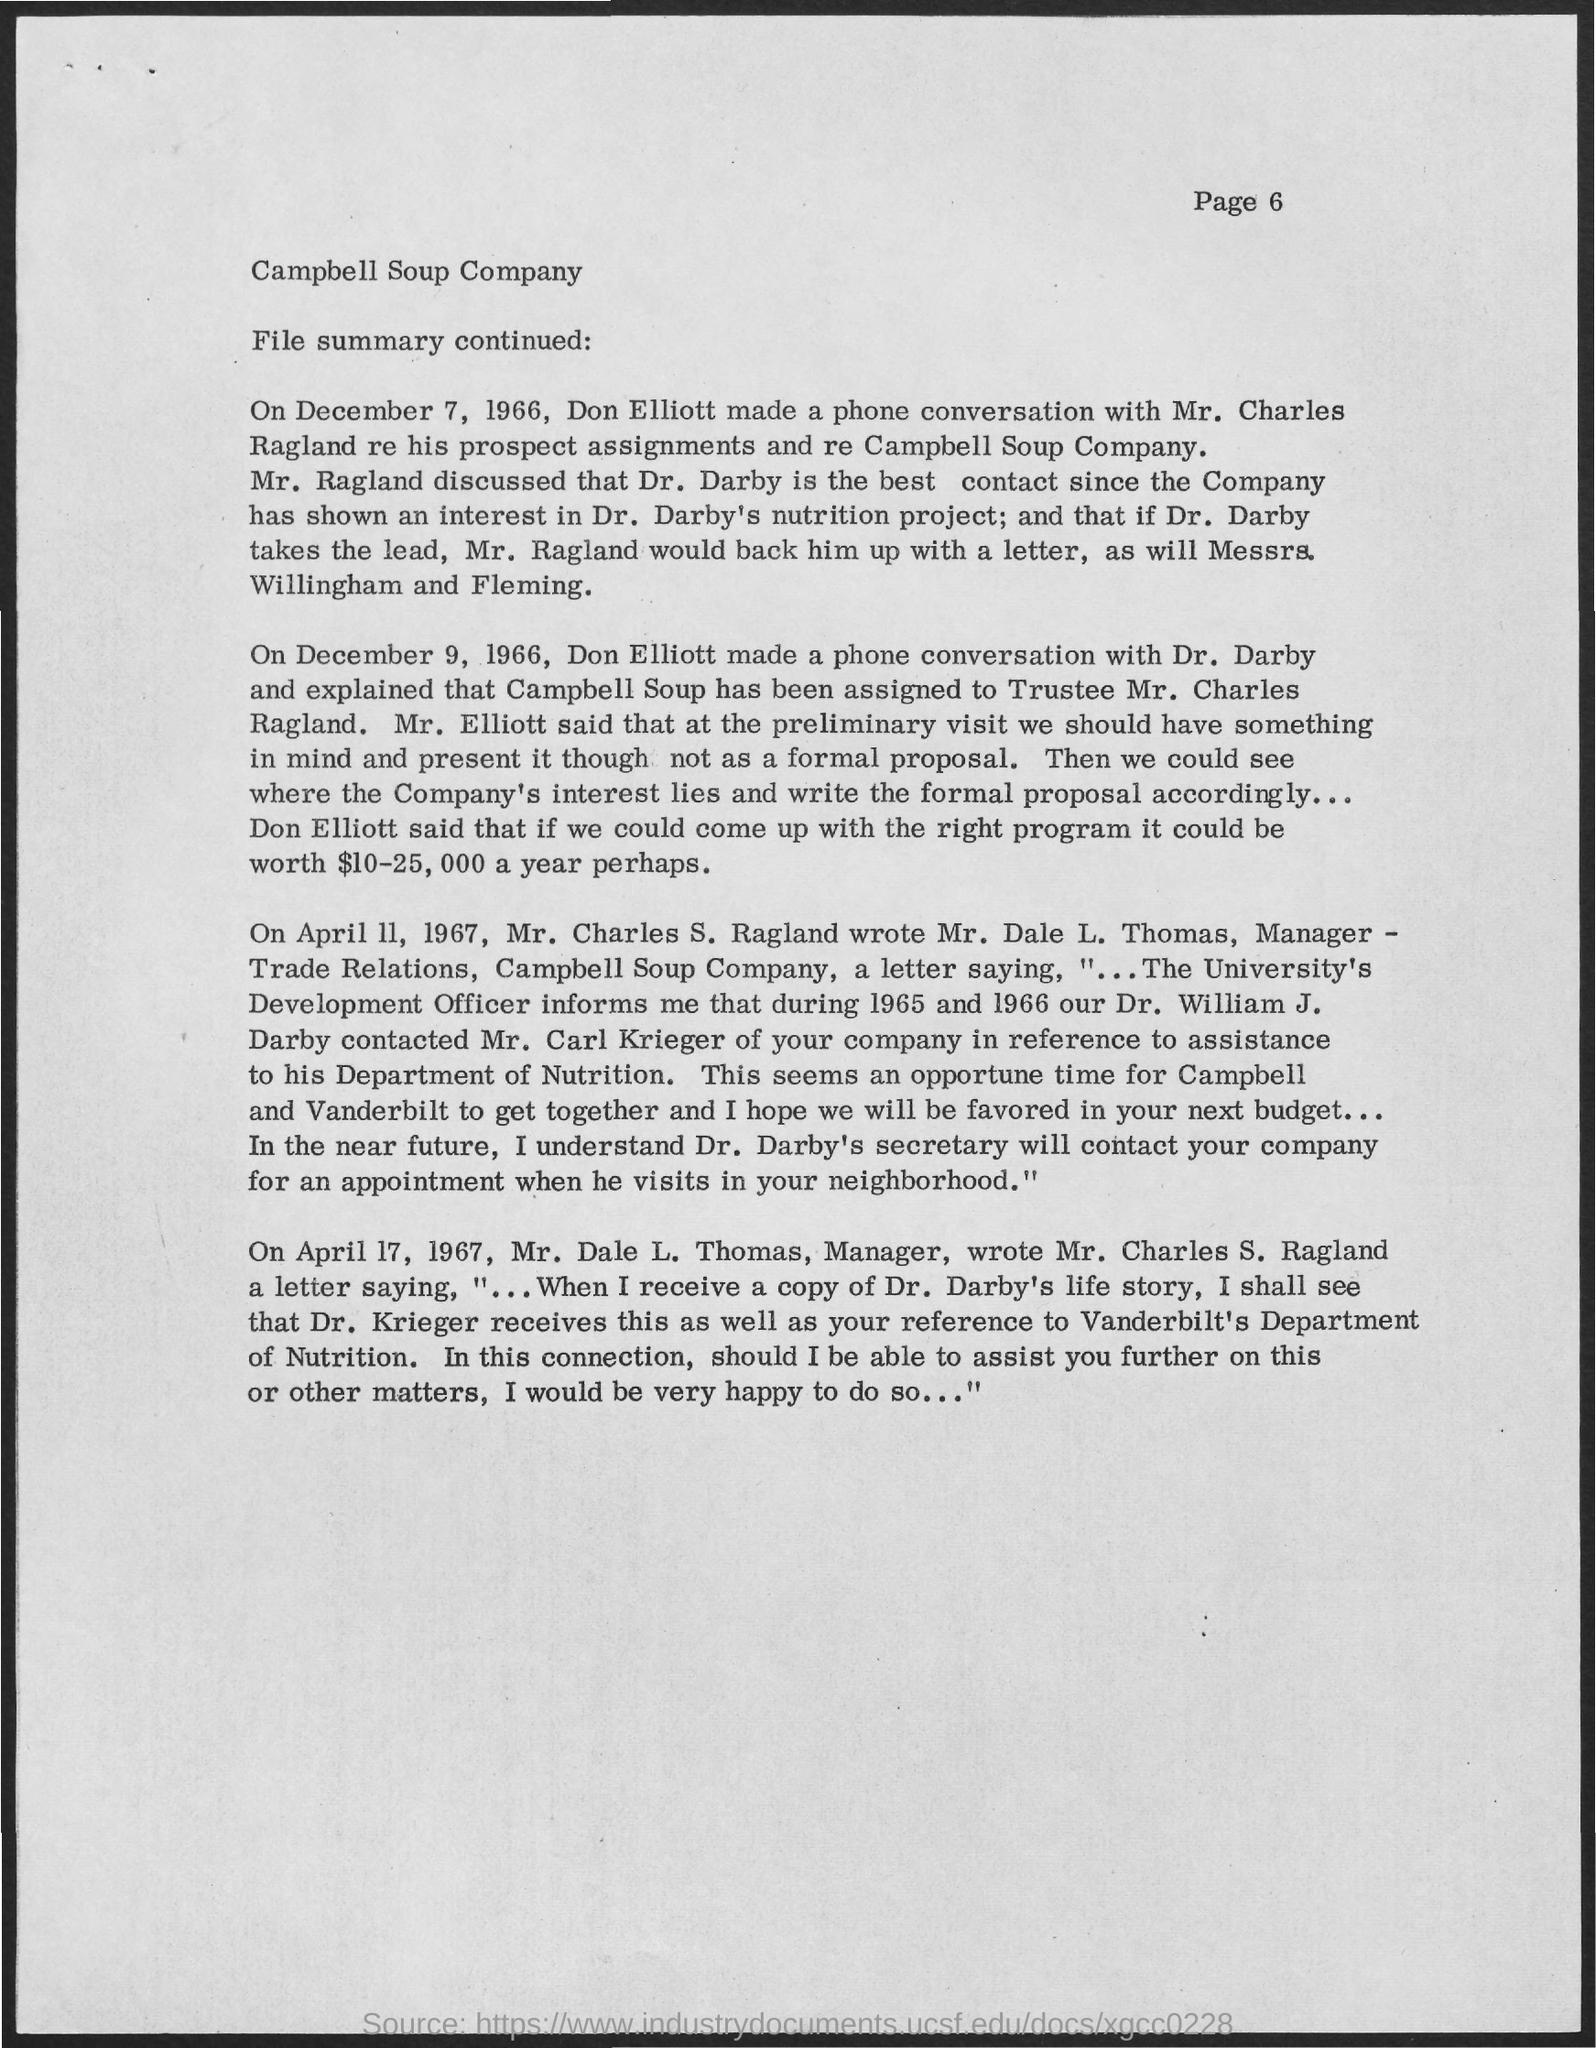What is the page number mentioned ?
Provide a short and direct response. 6. On which date don elliott made a phone conversation with mr . charles ragland
Offer a terse response. December 7 , 1966. On which date don elliott made a phone conversation with dr. darby
Your answer should be very brief. December 9, 1966. Who is the manager of campbell soup company
Offer a very short reply. Mr. Dale L. Thomas. 